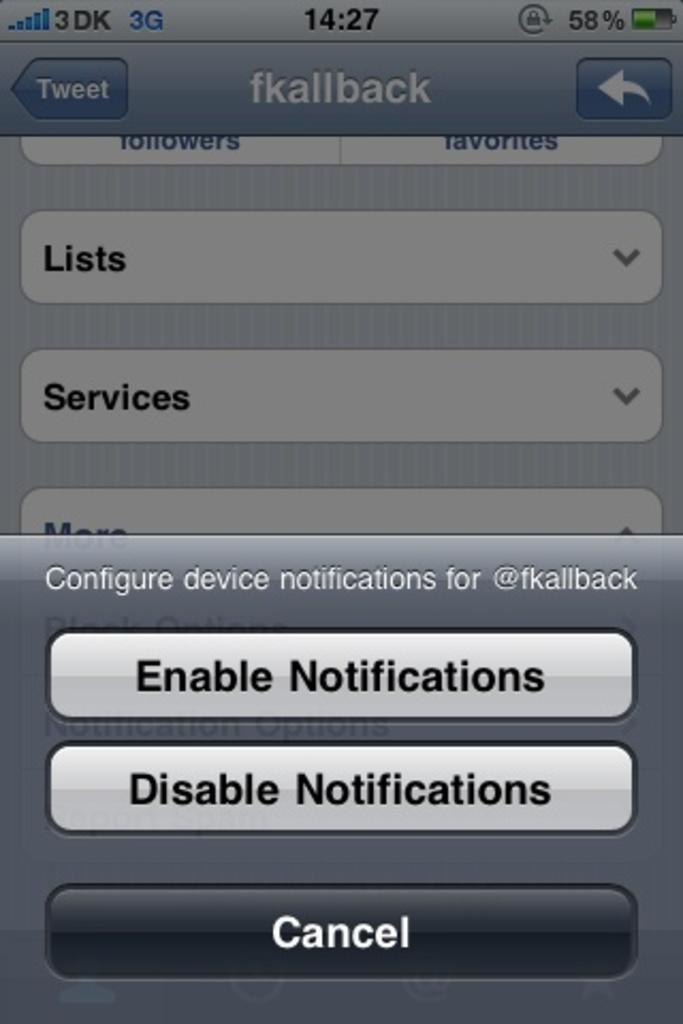<image>
Give a short and clear explanation of the subsequent image. the screen for an iphone with the options to enable and disable notifications. 